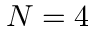Convert formula to latex. <formula><loc_0><loc_0><loc_500><loc_500>N = 4</formula> 